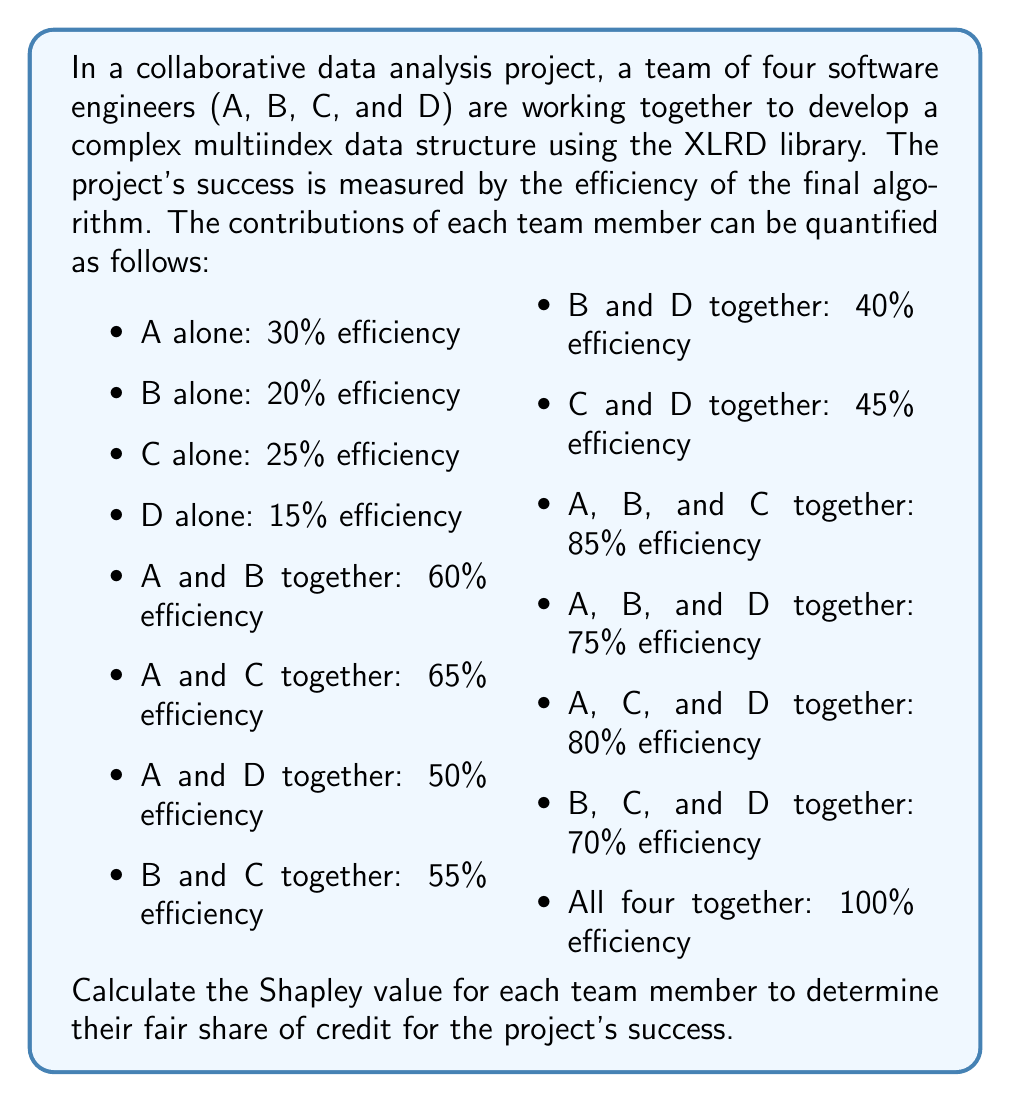What is the answer to this math problem? To calculate the Shapley value for each team member, we need to consider all possible permutations of the team and calculate the marginal contribution of each member in each permutation. The Shapley value is then the average of these marginal contributions.

For a team of 4 members, there are 4! = 24 possible permutations.

Let's calculate the marginal contribution for each member in each permutation:

1. Calculate marginal contributions:
   For each permutation, we'll calculate the contribution of each member when they join the coalition.

2. Sum up the marginal contributions:
   Add up all the marginal contributions for each member across all permutations.

3. Calculate the Shapley value:
   Divide the sum of marginal contributions by the number of permutations (24) to get the average.

Let's go through this process for each team member:

For member A:
- A joins first: 30% (6 permutations)
- A joins second:
  - After B: 60% - 20% = 40% (2 permutations)
  - After C: 65% - 25% = 40% (2 permutations)
  - After D: 50% - 15% = 35% (2 permutations)
- A joins third:
  - After B and C: 85% - 55% = 30% (2 permutations)
  - After B and D: 75% - 40% = 35% (2 permutations)
  - After C and D: 80% - 45% = 35% (2 permutations)
- A joins last: 100% - 70% = 30% (6 permutations)

Sum of A's marginal contributions:
$$(6 \times 30) + (2 \times 40) + (2 \times 40) + (2 \times 35) + (2 \times 30) + (2 \times 35) + (2 \times 35) + (6 \times 30) = 810$$

Shapley value for A: $\frac{810}{24} = 33.75$

Similarly, we calculate for B, C, and D:

For member B:
Sum of B's marginal contributions: 570
Shapley value for B: $\frac{570}{24} = 23.75$

For member C:
Sum of C's marginal contributions: 660
Shapley value for C: $\frac{660}{24} = 27.5$

For member D:
Sum of D's marginal contributions: 360
Shapley value for D: $\frac{360}{24} = 15$

We can verify that the sum of Shapley values equals the total value of the grand coalition:
$$33.75 + 23.75 + 27.5 + 15 = 100$$
Answer: The Shapley values for each team member are:

A: 33.75
B: 23.75
C: 27.5
D: 15 